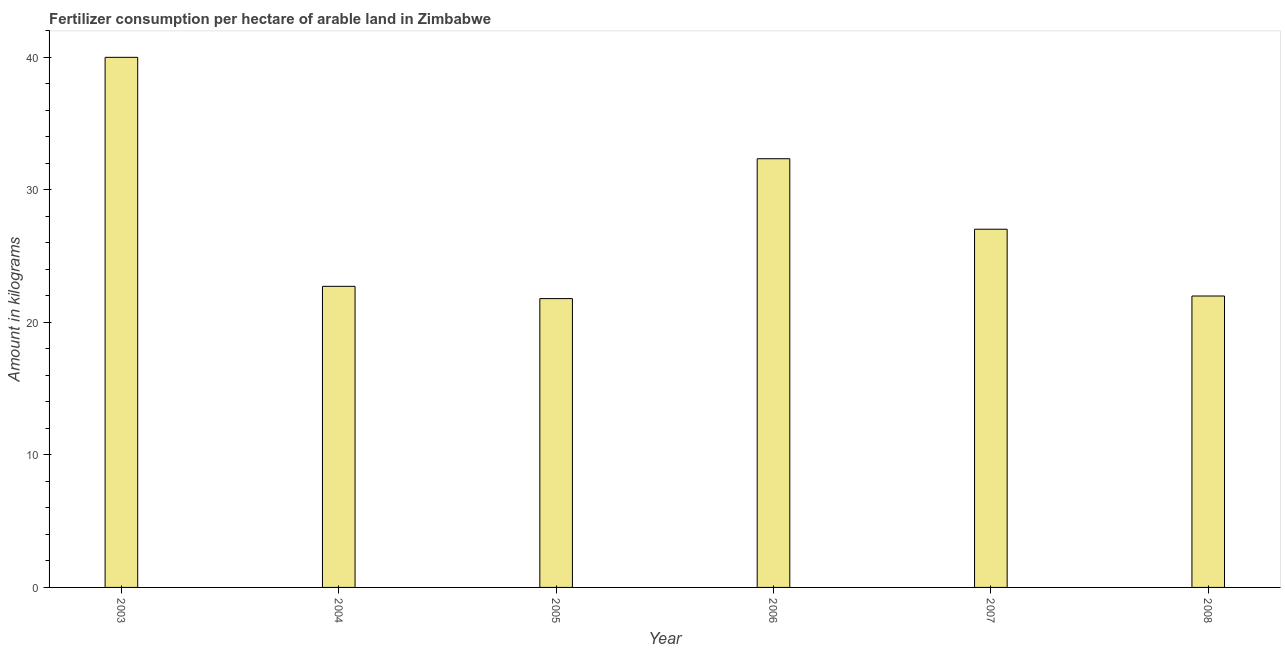Does the graph contain grids?
Your response must be concise. No. What is the title of the graph?
Provide a succinct answer. Fertilizer consumption per hectare of arable land in Zimbabwe . What is the label or title of the X-axis?
Give a very brief answer. Year. What is the label or title of the Y-axis?
Provide a short and direct response. Amount in kilograms. What is the amount of fertilizer consumption in 2005?
Give a very brief answer. 21.8. Across all years, what is the maximum amount of fertilizer consumption?
Your answer should be very brief. 40.01. Across all years, what is the minimum amount of fertilizer consumption?
Keep it short and to the point. 21.8. In which year was the amount of fertilizer consumption maximum?
Your answer should be compact. 2003. What is the sum of the amount of fertilizer consumption?
Offer a terse response. 165.92. What is the difference between the amount of fertilizer consumption in 2003 and 2005?
Make the answer very short. 18.21. What is the average amount of fertilizer consumption per year?
Give a very brief answer. 27.65. What is the median amount of fertilizer consumption?
Your response must be concise. 24.88. In how many years, is the amount of fertilizer consumption greater than 4 kg?
Your response must be concise. 6. What is the ratio of the amount of fertilizer consumption in 2003 to that in 2007?
Offer a terse response. 1.48. Is the difference between the amount of fertilizer consumption in 2004 and 2006 greater than the difference between any two years?
Ensure brevity in your answer.  No. What is the difference between the highest and the second highest amount of fertilizer consumption?
Provide a succinct answer. 7.65. Is the sum of the amount of fertilizer consumption in 2005 and 2007 greater than the maximum amount of fertilizer consumption across all years?
Provide a short and direct response. Yes. What is the difference between the highest and the lowest amount of fertilizer consumption?
Your response must be concise. 18.21. How many bars are there?
Offer a terse response. 6. Are all the bars in the graph horizontal?
Offer a terse response. No. How many years are there in the graph?
Offer a very short reply. 6. What is the difference between two consecutive major ticks on the Y-axis?
Provide a short and direct response. 10. What is the Amount in kilograms of 2003?
Provide a succinct answer. 40.01. What is the Amount in kilograms of 2004?
Offer a very short reply. 22.72. What is the Amount in kilograms of 2005?
Give a very brief answer. 21.8. What is the Amount in kilograms of 2006?
Your response must be concise. 32.36. What is the Amount in kilograms in 2007?
Give a very brief answer. 27.04. What is the Amount in kilograms in 2008?
Offer a terse response. 21.99. What is the difference between the Amount in kilograms in 2003 and 2004?
Offer a terse response. 17.28. What is the difference between the Amount in kilograms in 2003 and 2005?
Your answer should be very brief. 18.21. What is the difference between the Amount in kilograms in 2003 and 2006?
Your response must be concise. 7.65. What is the difference between the Amount in kilograms in 2003 and 2007?
Your response must be concise. 12.97. What is the difference between the Amount in kilograms in 2003 and 2008?
Make the answer very short. 18.01. What is the difference between the Amount in kilograms in 2004 and 2005?
Your response must be concise. 0.92. What is the difference between the Amount in kilograms in 2004 and 2006?
Keep it short and to the point. -9.63. What is the difference between the Amount in kilograms in 2004 and 2007?
Make the answer very short. -4.31. What is the difference between the Amount in kilograms in 2004 and 2008?
Give a very brief answer. 0.73. What is the difference between the Amount in kilograms in 2005 and 2006?
Provide a short and direct response. -10.56. What is the difference between the Amount in kilograms in 2005 and 2007?
Your response must be concise. -5.24. What is the difference between the Amount in kilograms in 2005 and 2008?
Offer a terse response. -0.19. What is the difference between the Amount in kilograms in 2006 and 2007?
Your answer should be very brief. 5.32. What is the difference between the Amount in kilograms in 2006 and 2008?
Provide a short and direct response. 10.36. What is the difference between the Amount in kilograms in 2007 and 2008?
Offer a terse response. 5.04. What is the ratio of the Amount in kilograms in 2003 to that in 2004?
Your answer should be very brief. 1.76. What is the ratio of the Amount in kilograms in 2003 to that in 2005?
Provide a succinct answer. 1.83. What is the ratio of the Amount in kilograms in 2003 to that in 2006?
Make the answer very short. 1.24. What is the ratio of the Amount in kilograms in 2003 to that in 2007?
Your answer should be compact. 1.48. What is the ratio of the Amount in kilograms in 2003 to that in 2008?
Offer a very short reply. 1.82. What is the ratio of the Amount in kilograms in 2004 to that in 2005?
Keep it short and to the point. 1.04. What is the ratio of the Amount in kilograms in 2004 to that in 2006?
Provide a succinct answer. 0.7. What is the ratio of the Amount in kilograms in 2004 to that in 2007?
Offer a terse response. 0.84. What is the ratio of the Amount in kilograms in 2004 to that in 2008?
Provide a succinct answer. 1.03. What is the ratio of the Amount in kilograms in 2005 to that in 2006?
Provide a short and direct response. 0.67. What is the ratio of the Amount in kilograms in 2005 to that in 2007?
Provide a short and direct response. 0.81. What is the ratio of the Amount in kilograms in 2006 to that in 2007?
Provide a succinct answer. 1.2. What is the ratio of the Amount in kilograms in 2006 to that in 2008?
Your answer should be compact. 1.47. What is the ratio of the Amount in kilograms in 2007 to that in 2008?
Keep it short and to the point. 1.23. 